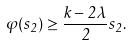<formula> <loc_0><loc_0><loc_500><loc_500>\varphi ( s _ { 2 } ) \geq \frac { k - 2 \lambda } { 2 } s _ { 2 } .</formula> 